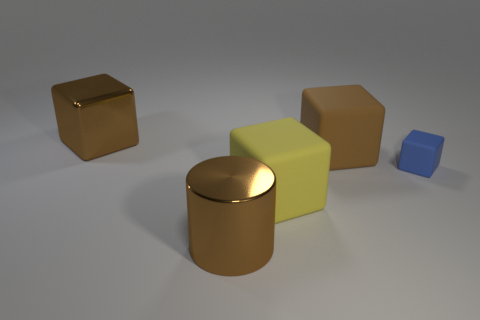Which object seems out of place in terms of color, and why? The small blue cube on the far right appears out of place color-wise. While the other objects share a warm color palette of browns and yellows, the blue hue of the small cube adds a cool contrast, making it stand out in the assembly of objects. Does the blue cube interact with light differently because of its color? Color can affect the perception of how light interacts with an object. In this case, the blue cube reflects less light than the shiny objects, due to its matte finish, but its distinct color can make the interplay of light more noticeable compared to the similarly matte but neutrally colored objects. 